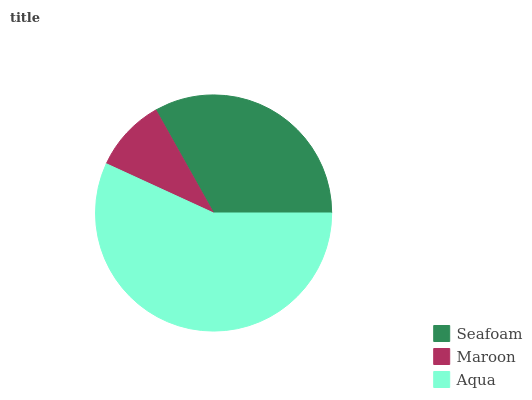Is Maroon the minimum?
Answer yes or no. Yes. Is Aqua the maximum?
Answer yes or no. Yes. Is Aqua the minimum?
Answer yes or no. No. Is Maroon the maximum?
Answer yes or no. No. Is Aqua greater than Maroon?
Answer yes or no. Yes. Is Maroon less than Aqua?
Answer yes or no. Yes. Is Maroon greater than Aqua?
Answer yes or no. No. Is Aqua less than Maroon?
Answer yes or no. No. Is Seafoam the high median?
Answer yes or no. Yes. Is Seafoam the low median?
Answer yes or no. Yes. Is Maroon the high median?
Answer yes or no. No. Is Maroon the low median?
Answer yes or no. No. 